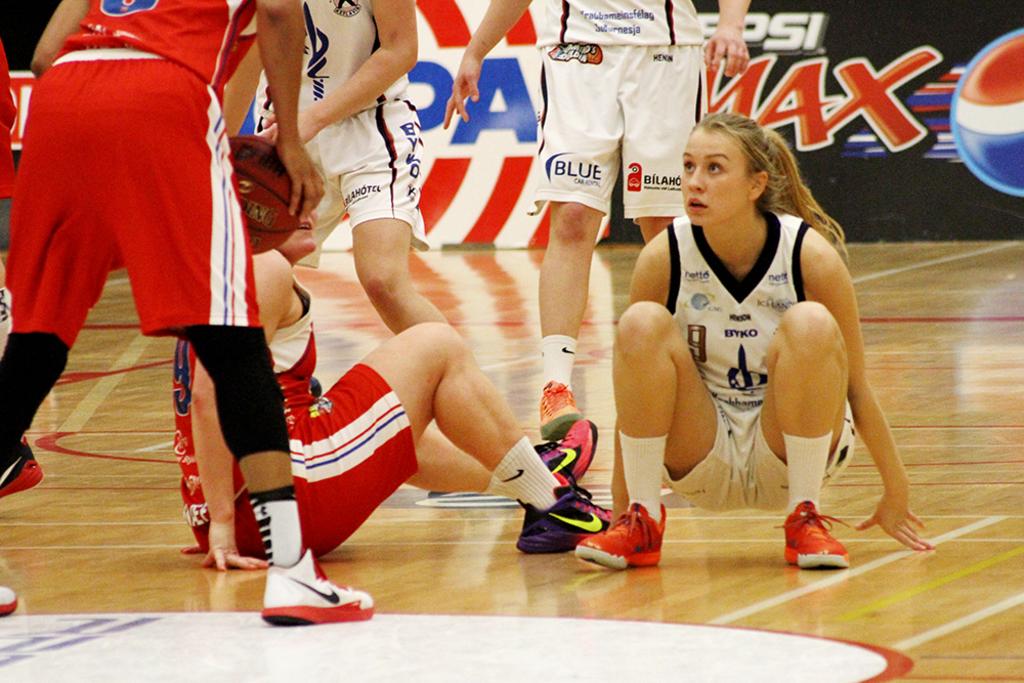What soft drink is being advertised on this court?
Make the answer very short. Pepsi max. 